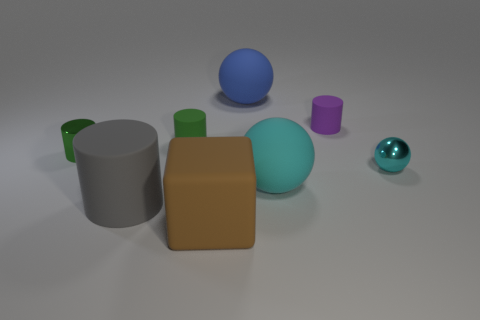In terms of lighting in the image, where does it appear to be coming from? The lighting in the image seems to be diffused overhead lighting, likely from an artificial source. This is indicated by the soft shadows cast by the objects onto the floor, emanating outward from a point above the center of the scene. 